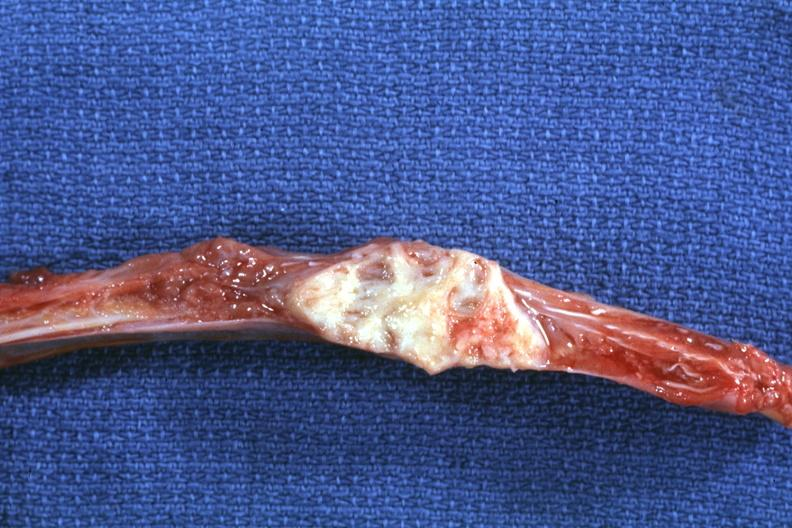does this image show rib with well shown lesion?
Answer the question using a single word or phrase. Yes 